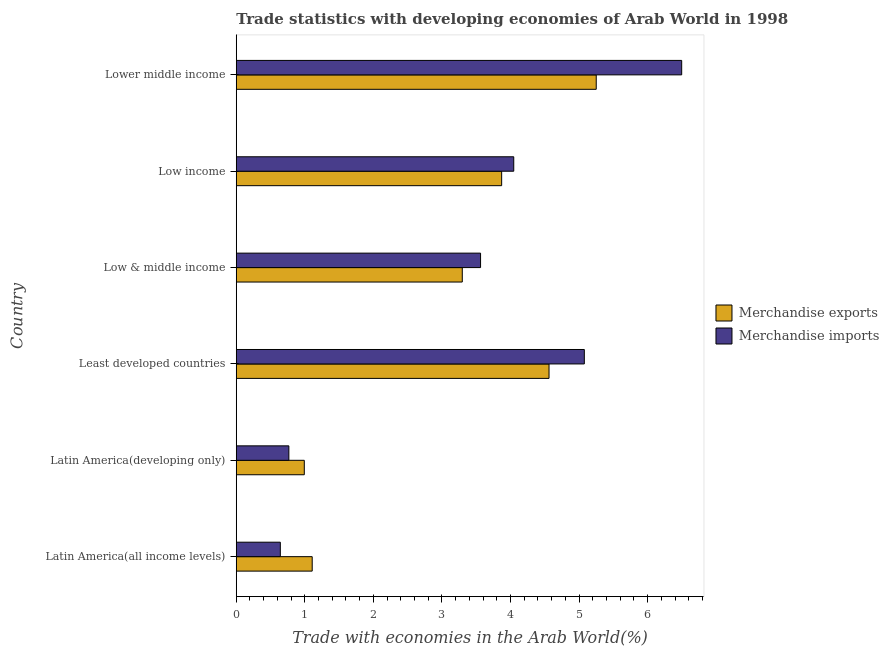How many groups of bars are there?
Ensure brevity in your answer.  6. Are the number of bars per tick equal to the number of legend labels?
Keep it short and to the point. Yes. What is the label of the 5th group of bars from the top?
Give a very brief answer. Latin America(developing only). What is the merchandise imports in Latin America(all income levels)?
Your response must be concise. 0.64. Across all countries, what is the maximum merchandise imports?
Give a very brief answer. 6.5. Across all countries, what is the minimum merchandise exports?
Offer a terse response. 0.99. In which country was the merchandise imports maximum?
Keep it short and to the point. Lower middle income. In which country was the merchandise imports minimum?
Keep it short and to the point. Latin America(all income levels). What is the total merchandise exports in the graph?
Keep it short and to the point. 19.08. What is the difference between the merchandise imports in Low & middle income and that in Low income?
Make the answer very short. -0.48. What is the difference between the merchandise imports in Least developed countries and the merchandise exports in Latin America(all income levels)?
Give a very brief answer. 3.97. What is the average merchandise imports per country?
Offer a very short reply. 3.43. What is the difference between the merchandise exports and merchandise imports in Low & middle income?
Give a very brief answer. -0.27. In how many countries, is the merchandise exports greater than 0.8 %?
Provide a succinct answer. 6. What is the ratio of the merchandise exports in Latin America(all income levels) to that in Lower middle income?
Offer a terse response. 0.21. Is the merchandise imports in Latin America(all income levels) less than that in Low income?
Give a very brief answer. Yes. Is the difference between the merchandise imports in Latin America(developing only) and Low income greater than the difference between the merchandise exports in Latin America(developing only) and Low income?
Your answer should be very brief. No. What is the difference between the highest and the second highest merchandise imports?
Make the answer very short. 1.42. What is the difference between the highest and the lowest merchandise exports?
Give a very brief answer. 4.26. Is the sum of the merchandise exports in Latin America(all income levels) and Lower middle income greater than the maximum merchandise imports across all countries?
Offer a terse response. No. What does the 2nd bar from the bottom in Least developed countries represents?
Your answer should be very brief. Merchandise imports. How many bars are there?
Ensure brevity in your answer.  12. How many countries are there in the graph?
Provide a short and direct response. 6. Are the values on the major ticks of X-axis written in scientific E-notation?
Your answer should be compact. No. Does the graph contain any zero values?
Your answer should be very brief. No. How are the legend labels stacked?
Offer a terse response. Vertical. What is the title of the graph?
Your answer should be compact. Trade statistics with developing economies of Arab World in 1998. What is the label or title of the X-axis?
Your answer should be very brief. Trade with economies in the Arab World(%). What is the label or title of the Y-axis?
Provide a succinct answer. Country. What is the Trade with economies in the Arab World(%) in Merchandise exports in Latin America(all income levels)?
Your answer should be compact. 1.11. What is the Trade with economies in the Arab World(%) of Merchandise imports in Latin America(all income levels)?
Make the answer very short. 0.64. What is the Trade with economies in the Arab World(%) of Merchandise exports in Latin America(developing only)?
Your response must be concise. 0.99. What is the Trade with economies in the Arab World(%) of Merchandise imports in Latin America(developing only)?
Your answer should be very brief. 0.77. What is the Trade with economies in the Arab World(%) of Merchandise exports in Least developed countries?
Provide a short and direct response. 4.56. What is the Trade with economies in the Arab World(%) of Merchandise imports in Least developed countries?
Your answer should be compact. 5.08. What is the Trade with economies in the Arab World(%) of Merchandise exports in Low & middle income?
Offer a very short reply. 3.3. What is the Trade with economies in the Arab World(%) of Merchandise imports in Low & middle income?
Your response must be concise. 3.56. What is the Trade with economies in the Arab World(%) of Merchandise exports in Low income?
Your answer should be compact. 3.87. What is the Trade with economies in the Arab World(%) of Merchandise imports in Low income?
Provide a succinct answer. 4.05. What is the Trade with economies in the Arab World(%) in Merchandise exports in Lower middle income?
Make the answer very short. 5.25. What is the Trade with economies in the Arab World(%) of Merchandise imports in Lower middle income?
Ensure brevity in your answer.  6.5. Across all countries, what is the maximum Trade with economies in the Arab World(%) in Merchandise exports?
Make the answer very short. 5.25. Across all countries, what is the maximum Trade with economies in the Arab World(%) of Merchandise imports?
Your answer should be very brief. 6.5. Across all countries, what is the minimum Trade with economies in the Arab World(%) of Merchandise exports?
Your answer should be compact. 0.99. Across all countries, what is the minimum Trade with economies in the Arab World(%) in Merchandise imports?
Make the answer very short. 0.64. What is the total Trade with economies in the Arab World(%) in Merchandise exports in the graph?
Your answer should be very brief. 19.08. What is the total Trade with economies in the Arab World(%) in Merchandise imports in the graph?
Your answer should be compact. 20.59. What is the difference between the Trade with economies in the Arab World(%) of Merchandise exports in Latin America(all income levels) and that in Latin America(developing only)?
Provide a succinct answer. 0.12. What is the difference between the Trade with economies in the Arab World(%) of Merchandise imports in Latin America(all income levels) and that in Latin America(developing only)?
Give a very brief answer. -0.12. What is the difference between the Trade with economies in the Arab World(%) in Merchandise exports in Latin America(all income levels) and that in Least developed countries?
Make the answer very short. -3.45. What is the difference between the Trade with economies in the Arab World(%) in Merchandise imports in Latin America(all income levels) and that in Least developed countries?
Make the answer very short. -4.43. What is the difference between the Trade with economies in the Arab World(%) in Merchandise exports in Latin America(all income levels) and that in Low & middle income?
Your response must be concise. -2.19. What is the difference between the Trade with economies in the Arab World(%) of Merchandise imports in Latin America(all income levels) and that in Low & middle income?
Provide a succinct answer. -2.92. What is the difference between the Trade with economies in the Arab World(%) in Merchandise exports in Latin America(all income levels) and that in Low income?
Offer a very short reply. -2.76. What is the difference between the Trade with economies in the Arab World(%) in Merchandise imports in Latin America(all income levels) and that in Low income?
Offer a terse response. -3.4. What is the difference between the Trade with economies in the Arab World(%) of Merchandise exports in Latin America(all income levels) and that in Lower middle income?
Provide a short and direct response. -4.14. What is the difference between the Trade with economies in the Arab World(%) of Merchandise imports in Latin America(all income levels) and that in Lower middle income?
Provide a short and direct response. -5.85. What is the difference between the Trade with economies in the Arab World(%) in Merchandise exports in Latin America(developing only) and that in Least developed countries?
Your answer should be compact. -3.57. What is the difference between the Trade with economies in the Arab World(%) in Merchandise imports in Latin America(developing only) and that in Least developed countries?
Your response must be concise. -4.31. What is the difference between the Trade with economies in the Arab World(%) in Merchandise exports in Latin America(developing only) and that in Low & middle income?
Ensure brevity in your answer.  -2.3. What is the difference between the Trade with economies in the Arab World(%) of Merchandise imports in Latin America(developing only) and that in Low & middle income?
Your answer should be compact. -2.8. What is the difference between the Trade with economies in the Arab World(%) of Merchandise exports in Latin America(developing only) and that in Low income?
Give a very brief answer. -2.88. What is the difference between the Trade with economies in the Arab World(%) of Merchandise imports in Latin America(developing only) and that in Low income?
Give a very brief answer. -3.28. What is the difference between the Trade with economies in the Arab World(%) of Merchandise exports in Latin America(developing only) and that in Lower middle income?
Offer a very short reply. -4.26. What is the difference between the Trade with economies in the Arab World(%) of Merchandise imports in Latin America(developing only) and that in Lower middle income?
Provide a short and direct response. -5.73. What is the difference between the Trade with economies in the Arab World(%) in Merchandise exports in Least developed countries and that in Low & middle income?
Give a very brief answer. 1.27. What is the difference between the Trade with economies in the Arab World(%) in Merchandise imports in Least developed countries and that in Low & middle income?
Your answer should be very brief. 1.51. What is the difference between the Trade with economies in the Arab World(%) in Merchandise exports in Least developed countries and that in Low income?
Provide a short and direct response. 0.69. What is the difference between the Trade with economies in the Arab World(%) of Merchandise imports in Least developed countries and that in Low income?
Provide a short and direct response. 1.03. What is the difference between the Trade with economies in the Arab World(%) of Merchandise exports in Least developed countries and that in Lower middle income?
Ensure brevity in your answer.  -0.69. What is the difference between the Trade with economies in the Arab World(%) in Merchandise imports in Least developed countries and that in Lower middle income?
Provide a short and direct response. -1.42. What is the difference between the Trade with economies in the Arab World(%) in Merchandise exports in Low & middle income and that in Low income?
Provide a succinct answer. -0.57. What is the difference between the Trade with economies in the Arab World(%) of Merchandise imports in Low & middle income and that in Low income?
Your answer should be very brief. -0.48. What is the difference between the Trade with economies in the Arab World(%) in Merchandise exports in Low & middle income and that in Lower middle income?
Your answer should be compact. -1.95. What is the difference between the Trade with economies in the Arab World(%) of Merchandise imports in Low & middle income and that in Lower middle income?
Provide a succinct answer. -2.93. What is the difference between the Trade with economies in the Arab World(%) of Merchandise exports in Low income and that in Lower middle income?
Your answer should be compact. -1.38. What is the difference between the Trade with economies in the Arab World(%) of Merchandise imports in Low income and that in Lower middle income?
Provide a short and direct response. -2.45. What is the difference between the Trade with economies in the Arab World(%) of Merchandise exports in Latin America(all income levels) and the Trade with economies in the Arab World(%) of Merchandise imports in Latin America(developing only)?
Provide a short and direct response. 0.34. What is the difference between the Trade with economies in the Arab World(%) in Merchandise exports in Latin America(all income levels) and the Trade with economies in the Arab World(%) in Merchandise imports in Least developed countries?
Offer a terse response. -3.97. What is the difference between the Trade with economies in the Arab World(%) of Merchandise exports in Latin America(all income levels) and the Trade with economies in the Arab World(%) of Merchandise imports in Low & middle income?
Ensure brevity in your answer.  -2.46. What is the difference between the Trade with economies in the Arab World(%) in Merchandise exports in Latin America(all income levels) and the Trade with economies in the Arab World(%) in Merchandise imports in Low income?
Your response must be concise. -2.94. What is the difference between the Trade with economies in the Arab World(%) of Merchandise exports in Latin America(all income levels) and the Trade with economies in the Arab World(%) of Merchandise imports in Lower middle income?
Offer a very short reply. -5.39. What is the difference between the Trade with economies in the Arab World(%) of Merchandise exports in Latin America(developing only) and the Trade with economies in the Arab World(%) of Merchandise imports in Least developed countries?
Your answer should be very brief. -4.08. What is the difference between the Trade with economies in the Arab World(%) in Merchandise exports in Latin America(developing only) and the Trade with economies in the Arab World(%) in Merchandise imports in Low & middle income?
Offer a very short reply. -2.57. What is the difference between the Trade with economies in the Arab World(%) in Merchandise exports in Latin America(developing only) and the Trade with economies in the Arab World(%) in Merchandise imports in Low income?
Keep it short and to the point. -3.05. What is the difference between the Trade with economies in the Arab World(%) of Merchandise exports in Latin America(developing only) and the Trade with economies in the Arab World(%) of Merchandise imports in Lower middle income?
Your response must be concise. -5.5. What is the difference between the Trade with economies in the Arab World(%) of Merchandise exports in Least developed countries and the Trade with economies in the Arab World(%) of Merchandise imports in Low & middle income?
Give a very brief answer. 1. What is the difference between the Trade with economies in the Arab World(%) in Merchandise exports in Least developed countries and the Trade with economies in the Arab World(%) in Merchandise imports in Low income?
Provide a short and direct response. 0.51. What is the difference between the Trade with economies in the Arab World(%) in Merchandise exports in Least developed countries and the Trade with economies in the Arab World(%) in Merchandise imports in Lower middle income?
Your answer should be compact. -1.93. What is the difference between the Trade with economies in the Arab World(%) in Merchandise exports in Low & middle income and the Trade with economies in the Arab World(%) in Merchandise imports in Low income?
Provide a succinct answer. -0.75. What is the difference between the Trade with economies in the Arab World(%) in Merchandise exports in Low & middle income and the Trade with economies in the Arab World(%) in Merchandise imports in Lower middle income?
Keep it short and to the point. -3.2. What is the difference between the Trade with economies in the Arab World(%) of Merchandise exports in Low income and the Trade with economies in the Arab World(%) of Merchandise imports in Lower middle income?
Your answer should be compact. -2.63. What is the average Trade with economies in the Arab World(%) in Merchandise exports per country?
Give a very brief answer. 3.18. What is the average Trade with economies in the Arab World(%) of Merchandise imports per country?
Your answer should be very brief. 3.43. What is the difference between the Trade with economies in the Arab World(%) of Merchandise exports and Trade with economies in the Arab World(%) of Merchandise imports in Latin America(all income levels)?
Your answer should be compact. 0.46. What is the difference between the Trade with economies in the Arab World(%) of Merchandise exports and Trade with economies in the Arab World(%) of Merchandise imports in Latin America(developing only)?
Make the answer very short. 0.23. What is the difference between the Trade with economies in the Arab World(%) of Merchandise exports and Trade with economies in the Arab World(%) of Merchandise imports in Least developed countries?
Keep it short and to the point. -0.51. What is the difference between the Trade with economies in the Arab World(%) in Merchandise exports and Trade with economies in the Arab World(%) in Merchandise imports in Low & middle income?
Your answer should be very brief. -0.27. What is the difference between the Trade with economies in the Arab World(%) of Merchandise exports and Trade with economies in the Arab World(%) of Merchandise imports in Low income?
Offer a terse response. -0.18. What is the difference between the Trade with economies in the Arab World(%) of Merchandise exports and Trade with economies in the Arab World(%) of Merchandise imports in Lower middle income?
Provide a succinct answer. -1.25. What is the ratio of the Trade with economies in the Arab World(%) in Merchandise exports in Latin America(all income levels) to that in Latin America(developing only)?
Your answer should be very brief. 1.12. What is the ratio of the Trade with economies in the Arab World(%) of Merchandise imports in Latin America(all income levels) to that in Latin America(developing only)?
Your answer should be very brief. 0.84. What is the ratio of the Trade with economies in the Arab World(%) of Merchandise exports in Latin America(all income levels) to that in Least developed countries?
Provide a short and direct response. 0.24. What is the ratio of the Trade with economies in the Arab World(%) of Merchandise imports in Latin America(all income levels) to that in Least developed countries?
Your answer should be very brief. 0.13. What is the ratio of the Trade with economies in the Arab World(%) in Merchandise exports in Latin America(all income levels) to that in Low & middle income?
Offer a very short reply. 0.34. What is the ratio of the Trade with economies in the Arab World(%) in Merchandise imports in Latin America(all income levels) to that in Low & middle income?
Your answer should be very brief. 0.18. What is the ratio of the Trade with economies in the Arab World(%) in Merchandise exports in Latin America(all income levels) to that in Low income?
Make the answer very short. 0.29. What is the ratio of the Trade with economies in the Arab World(%) of Merchandise imports in Latin America(all income levels) to that in Low income?
Keep it short and to the point. 0.16. What is the ratio of the Trade with economies in the Arab World(%) of Merchandise exports in Latin America(all income levels) to that in Lower middle income?
Provide a short and direct response. 0.21. What is the ratio of the Trade with economies in the Arab World(%) of Merchandise imports in Latin America(all income levels) to that in Lower middle income?
Provide a short and direct response. 0.1. What is the ratio of the Trade with economies in the Arab World(%) of Merchandise exports in Latin America(developing only) to that in Least developed countries?
Your answer should be very brief. 0.22. What is the ratio of the Trade with economies in the Arab World(%) in Merchandise imports in Latin America(developing only) to that in Least developed countries?
Your response must be concise. 0.15. What is the ratio of the Trade with economies in the Arab World(%) in Merchandise exports in Latin America(developing only) to that in Low & middle income?
Your answer should be very brief. 0.3. What is the ratio of the Trade with economies in the Arab World(%) in Merchandise imports in Latin America(developing only) to that in Low & middle income?
Provide a succinct answer. 0.22. What is the ratio of the Trade with economies in the Arab World(%) of Merchandise exports in Latin America(developing only) to that in Low income?
Your answer should be compact. 0.26. What is the ratio of the Trade with economies in the Arab World(%) in Merchandise imports in Latin America(developing only) to that in Low income?
Your answer should be very brief. 0.19. What is the ratio of the Trade with economies in the Arab World(%) in Merchandise exports in Latin America(developing only) to that in Lower middle income?
Your answer should be compact. 0.19. What is the ratio of the Trade with economies in the Arab World(%) of Merchandise imports in Latin America(developing only) to that in Lower middle income?
Offer a very short reply. 0.12. What is the ratio of the Trade with economies in the Arab World(%) in Merchandise exports in Least developed countries to that in Low & middle income?
Give a very brief answer. 1.38. What is the ratio of the Trade with economies in the Arab World(%) in Merchandise imports in Least developed countries to that in Low & middle income?
Make the answer very short. 1.42. What is the ratio of the Trade with economies in the Arab World(%) in Merchandise exports in Least developed countries to that in Low income?
Your answer should be very brief. 1.18. What is the ratio of the Trade with economies in the Arab World(%) of Merchandise imports in Least developed countries to that in Low income?
Offer a terse response. 1.25. What is the ratio of the Trade with economies in the Arab World(%) of Merchandise exports in Least developed countries to that in Lower middle income?
Give a very brief answer. 0.87. What is the ratio of the Trade with economies in the Arab World(%) in Merchandise imports in Least developed countries to that in Lower middle income?
Your answer should be compact. 0.78. What is the ratio of the Trade with economies in the Arab World(%) of Merchandise exports in Low & middle income to that in Low income?
Your answer should be compact. 0.85. What is the ratio of the Trade with economies in the Arab World(%) in Merchandise imports in Low & middle income to that in Low income?
Keep it short and to the point. 0.88. What is the ratio of the Trade with economies in the Arab World(%) in Merchandise exports in Low & middle income to that in Lower middle income?
Ensure brevity in your answer.  0.63. What is the ratio of the Trade with economies in the Arab World(%) of Merchandise imports in Low & middle income to that in Lower middle income?
Your response must be concise. 0.55. What is the ratio of the Trade with economies in the Arab World(%) of Merchandise exports in Low income to that in Lower middle income?
Provide a short and direct response. 0.74. What is the ratio of the Trade with economies in the Arab World(%) of Merchandise imports in Low income to that in Lower middle income?
Provide a short and direct response. 0.62. What is the difference between the highest and the second highest Trade with economies in the Arab World(%) of Merchandise exports?
Offer a very short reply. 0.69. What is the difference between the highest and the second highest Trade with economies in the Arab World(%) in Merchandise imports?
Your answer should be compact. 1.42. What is the difference between the highest and the lowest Trade with economies in the Arab World(%) of Merchandise exports?
Ensure brevity in your answer.  4.26. What is the difference between the highest and the lowest Trade with economies in the Arab World(%) of Merchandise imports?
Provide a succinct answer. 5.85. 